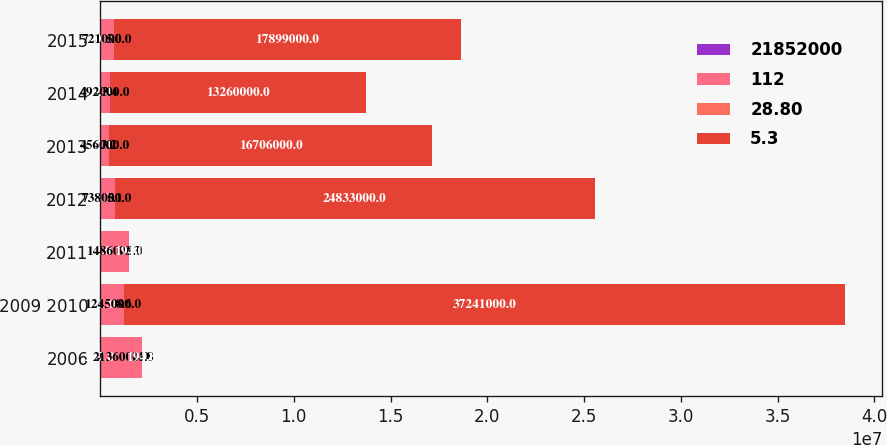<chart> <loc_0><loc_0><loc_500><loc_500><stacked_bar_chart><ecel><fcel>2006<fcel>2009 2010<fcel>2011<fcel>2012<fcel>2013<fcel>2014<fcel>2015<nl><fcel>2.1852e+07<fcel>247<fcel>141<fcel>72<fcel>34<fcel>29<fcel>22<fcel>30<nl><fcel>112<fcel>2.136e+06<fcel>1.245e+06<fcel>1.486e+06<fcel>738000<fcel>456000<fcel>492000<fcel>721000<nl><fcel>28.8<fcel>14.8<fcel>8.6<fcel>10.3<fcel>5.1<fcel>3.2<fcel>3.4<fcel>5<nl><fcel>5.3<fcel>194<fcel>3.7241e+07<fcel>194<fcel>2.4833e+07<fcel>1.6706e+07<fcel>1.326e+07<fcel>1.7899e+07<nl></chart> 